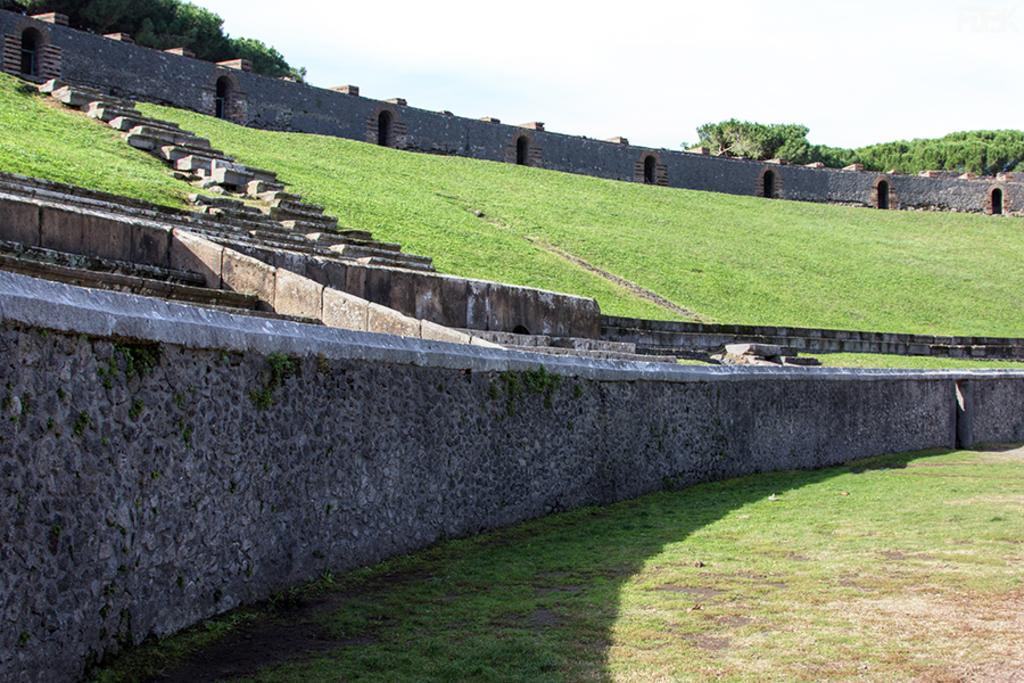What type of architectural feature can be seen in the image? There are stairs in the image. What is located near the stairs in the image? There is a wall in the image. What other structures can be seen in the image? There are other structures in the image. What is in the center of the image? There is grass in the center of the image. What can be seen in the background of the image? There are many trees in the background of the image. What is visible at the top of the image? The sky is visible at the top of the image. What can be observed in the sky? Clouds are present in the sky. Where is the sink located in the image? There is no sink present in the image. Are there any fairies visible in the image? There are no fairies present in the image. 